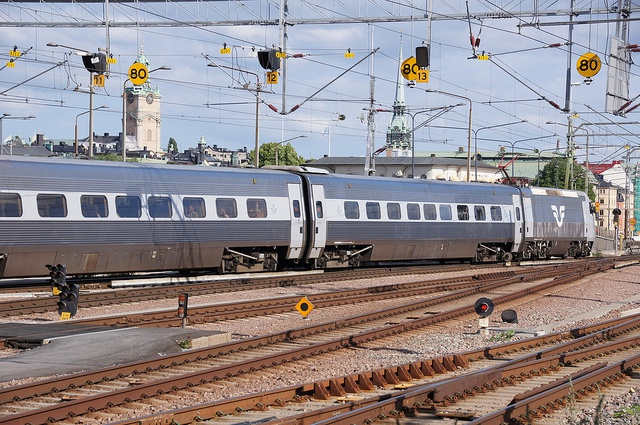Describe the objects in this image and their specific colors. I can see train in black, gray, darkgray, and lightgray tones, traffic light in black and gray tones, traffic light in black, gray, and darkgray tones, traffic light in black and gray tones, and traffic light in black, gray, and lightgray tones in this image. 